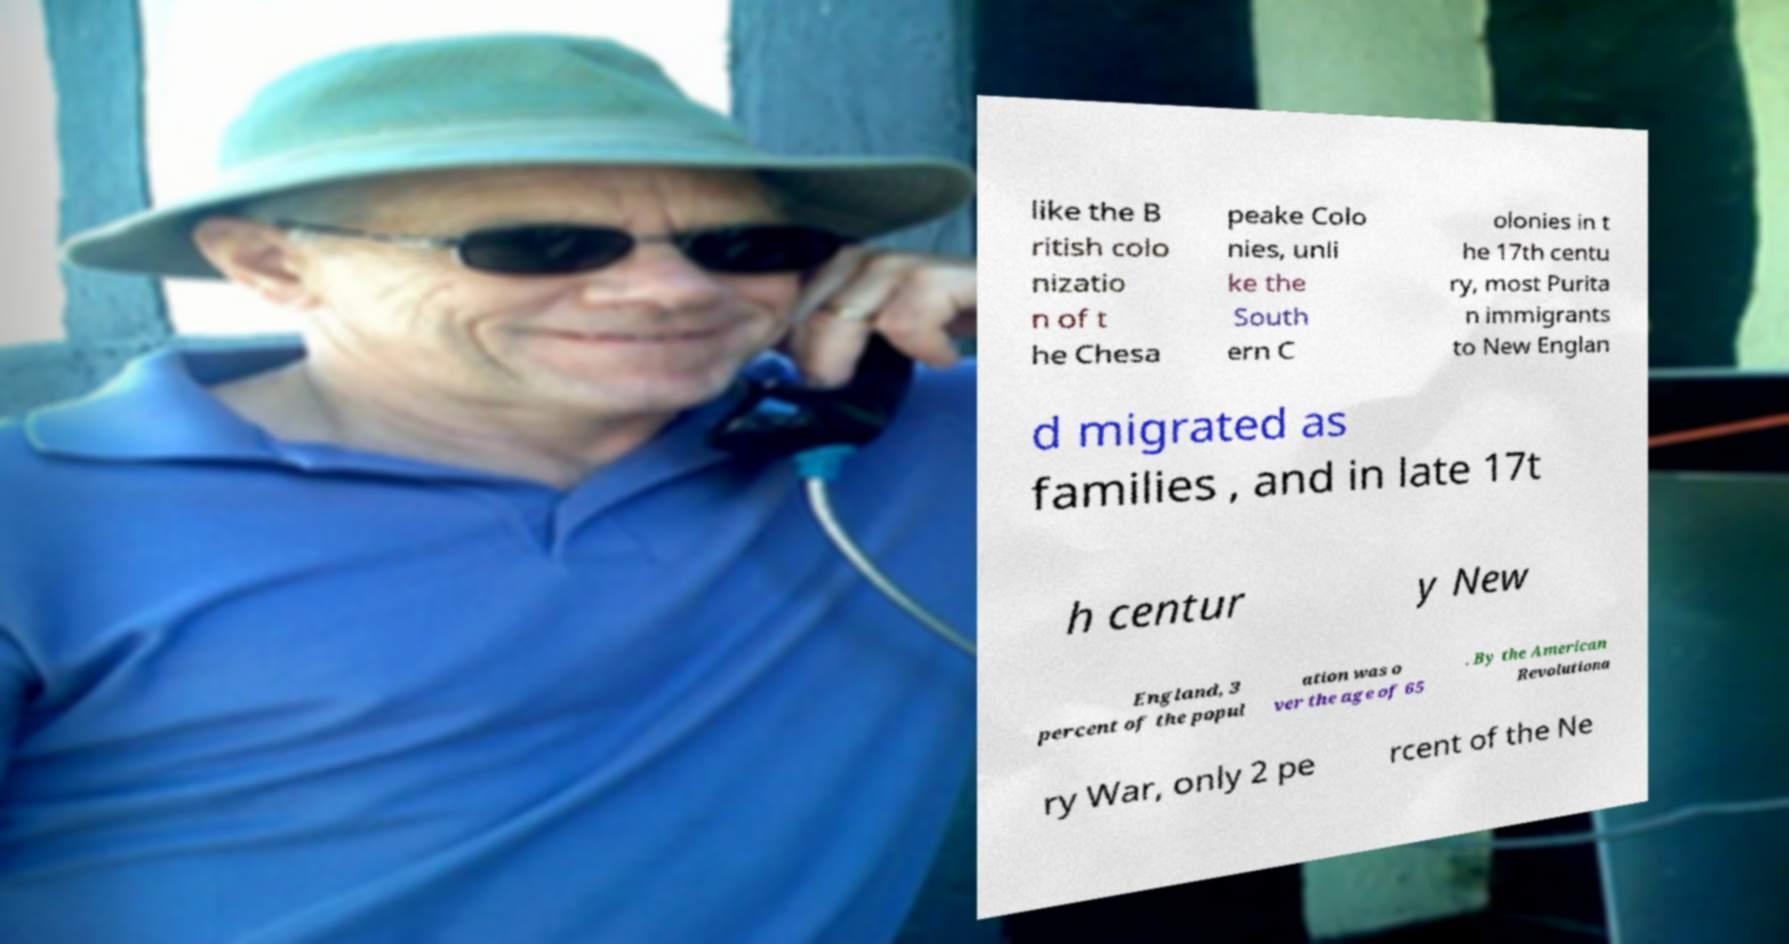Can you read and provide the text displayed in the image?This photo seems to have some interesting text. Can you extract and type it out for me? like the B ritish colo nizatio n of t he Chesa peake Colo nies, unli ke the South ern C olonies in t he 17th centu ry, most Purita n immigrants to New Englan d migrated as families , and in late 17t h centur y New England, 3 percent of the popul ation was o ver the age of 65 . By the American Revolutiona ry War, only 2 pe rcent of the Ne 